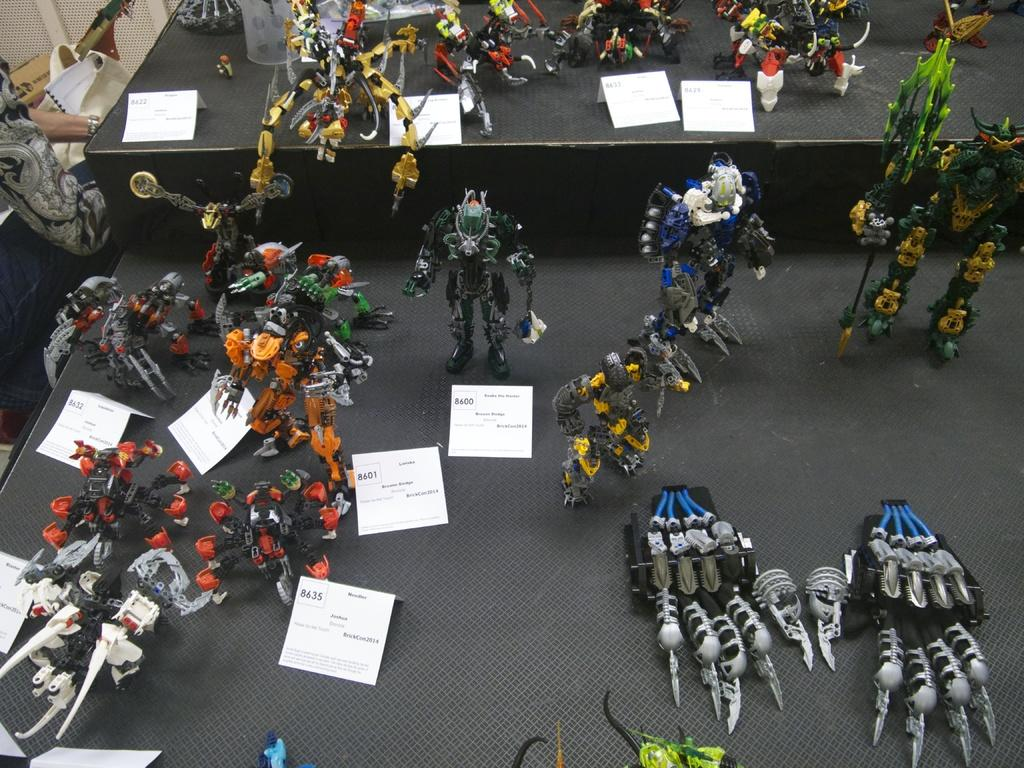What can be seen in abundance in the image? There are many toys in the image. What information is displayed on the objects in the image? There are price boards on the objects in the image. Where can a person's hands be seen in the image? A person's hands are visible on the left side of the toys. What type of coal is being used to power the toys in the image? There is no coal present in the image, and the toys do not require power. 